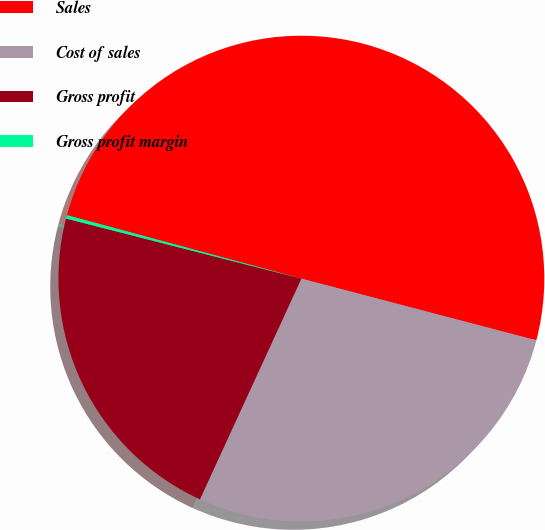Convert chart. <chart><loc_0><loc_0><loc_500><loc_500><pie_chart><fcel>Sales<fcel>Cost of sales<fcel>Gross profit<fcel>Gross profit margin<nl><fcel>49.88%<fcel>27.77%<fcel>22.12%<fcel>0.23%<nl></chart> 